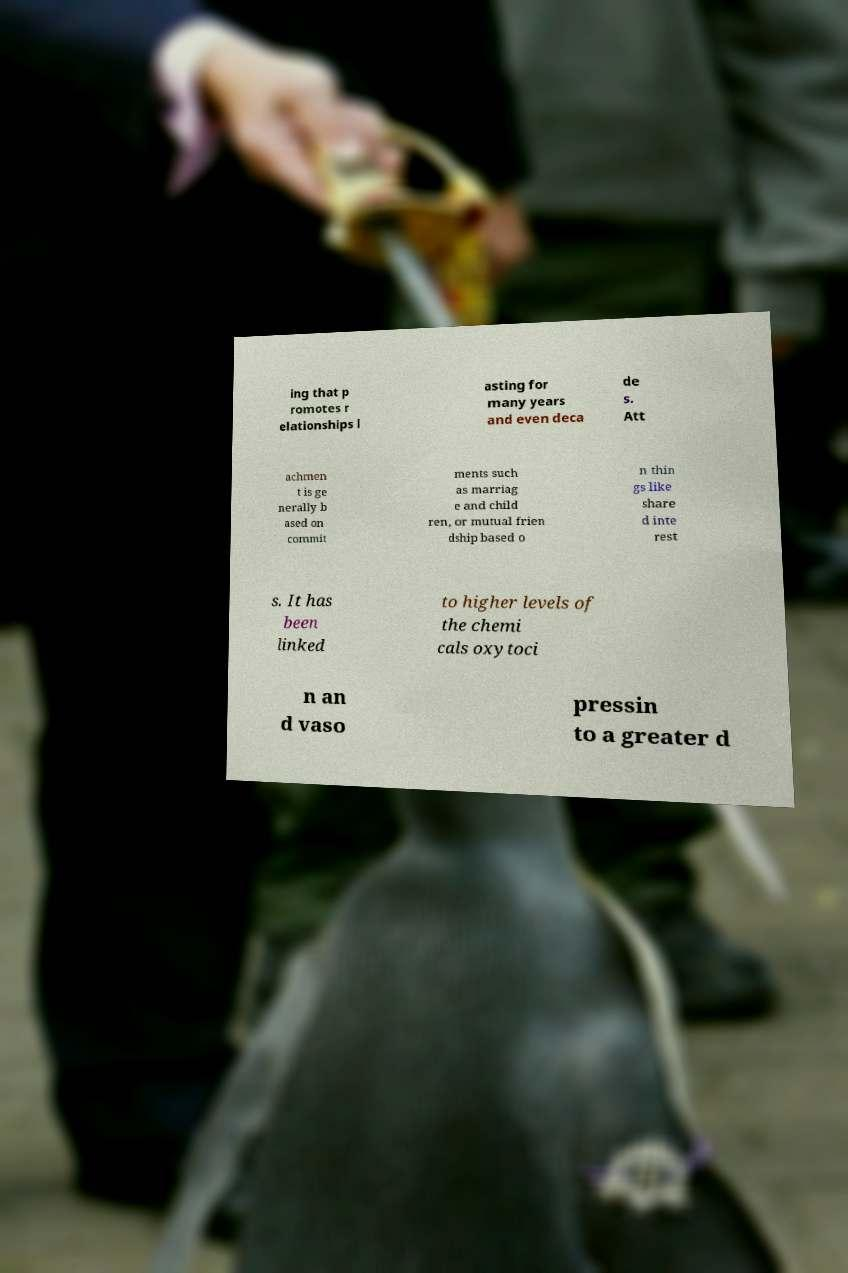Could you assist in decoding the text presented in this image and type it out clearly? ing that p romotes r elationships l asting for many years and even deca de s. Att achmen t is ge nerally b ased on commit ments such as marriag e and child ren, or mutual frien dship based o n thin gs like share d inte rest s. It has been linked to higher levels of the chemi cals oxytoci n an d vaso pressin to a greater d 